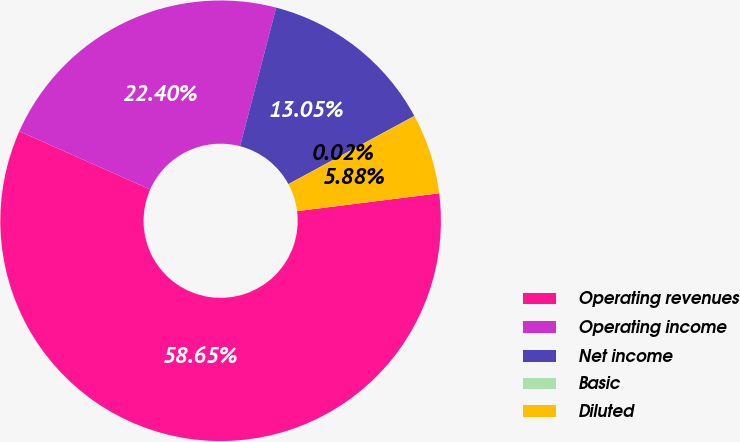Convert chart to OTSL. <chart><loc_0><loc_0><loc_500><loc_500><pie_chart><fcel>Operating revenues<fcel>Operating income<fcel>Net income<fcel>Basic<fcel>Diluted<nl><fcel>58.65%<fcel>22.4%<fcel>13.05%<fcel>0.02%<fcel>5.88%<nl></chart> 